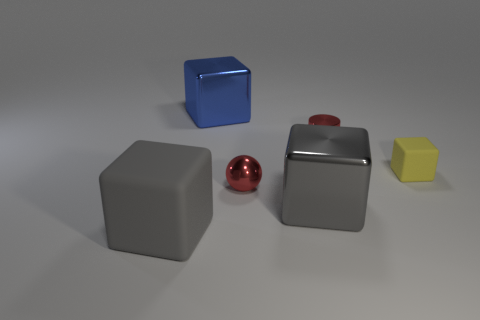How many small red metallic objects are there?
Your answer should be compact. 2. What number of blocks are on the left side of the yellow block and in front of the cylinder?
Offer a terse response. 2. What material is the tiny red cylinder?
Provide a short and direct response. Metal. Are any big gray objects visible?
Give a very brief answer. Yes. The matte block to the right of the large gray rubber block is what color?
Make the answer very short. Yellow. There is a large gray object on the right side of the big gray cube on the left side of the small shiny sphere; what number of large shiny things are behind it?
Keep it short and to the point. 1. There is a thing that is both on the left side of the sphere and behind the tiny red sphere; what material is it?
Give a very brief answer. Metal. Is the red ball made of the same material as the big thing that is right of the large blue metallic thing?
Offer a terse response. Yes. Are there more gray metallic things behind the large rubber object than gray objects that are behind the yellow block?
Provide a short and direct response. Yes. What is the shape of the big rubber thing?
Ensure brevity in your answer.  Cube. 